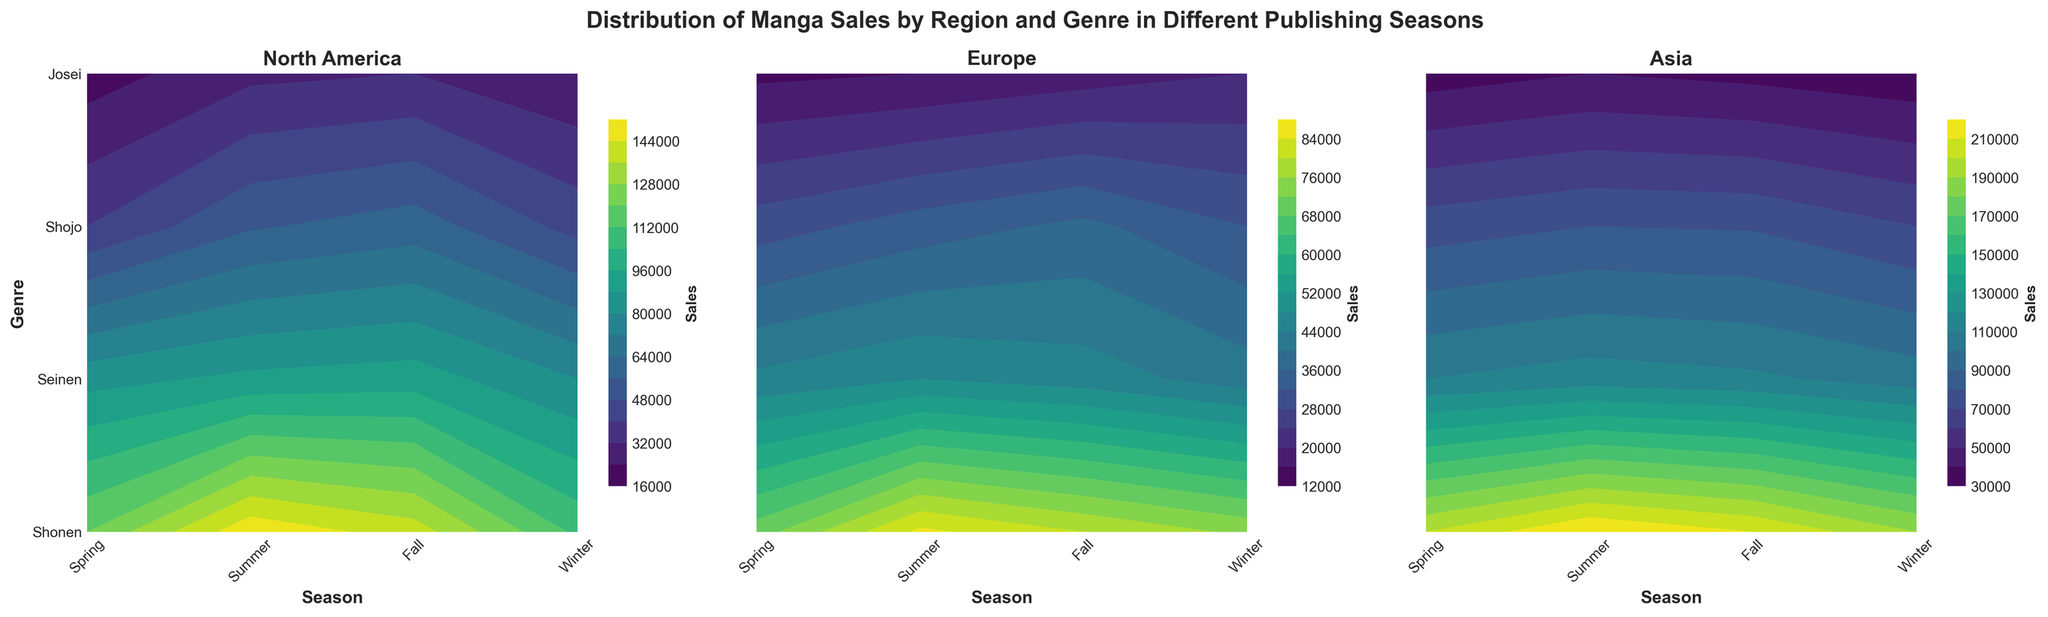Which season has the highest Shonen sales in Europe? By looking at the contour plot for Europe, find the season with the highest value on the Y-axis labeled 'Shonen'.
Answer: Summer What is the main title of the figure? The main title is located at the top of the figure, summarizing what the figure shows.
Answer: Distribution of Manga Sales by Region and Genre in Different Publishing Seasons Which genre shows the least sales in Asia during the Winter? Look at the contour plot for Asia, focus on the Winter season and identify which genre has the lowest contour level.
Answer: Josei Compare Shonen sales between North America and Asia in the summer. Which region has higher sales? Look at the contour plots for both regions, find the contour level for Shonen during the Summer season and compare the values.
Answer: Asia Which genre in North America has the most consistent sales across all seasons? Examine the contour plot for North America, identify the genre whose contour levels are most uniform (least variation) across all seasons.
Answer: Seinen What is the total sales of Shojo in Winter across all regions? Sum the sales values of Shojo in Winter for North America, Europe, and Asia.
Answer: 45000 + 32000 + 70000 = 147000 In which region does the genre Josei see a consistent increase in sales from Spring to Winter? Look at the contour plots for each region, examine the contour levels for Josei from Spring to Winter and identify where there is a consistent increase.
Answer: None In which season do Seinen sales peak in Asia? Find the highest contour level for Seinen in the contour plot for Asia and identify the corresponding season.
Answer: Summer Compare the genres with the lowest sales in Spring for North America and Europe. Are they the same? Identify the genre with the lowest contour level in Spring for both North America and Europe and compare them.
Answer: Yes How does the sales distribution within genres in Asia during Fall compare to other regions? Analyze the contour levels for all genres in Asia during Fall and compare the pattern to those in North America and Europe for the same season.
Answer: Asia has generally higher sales levels across all genres 